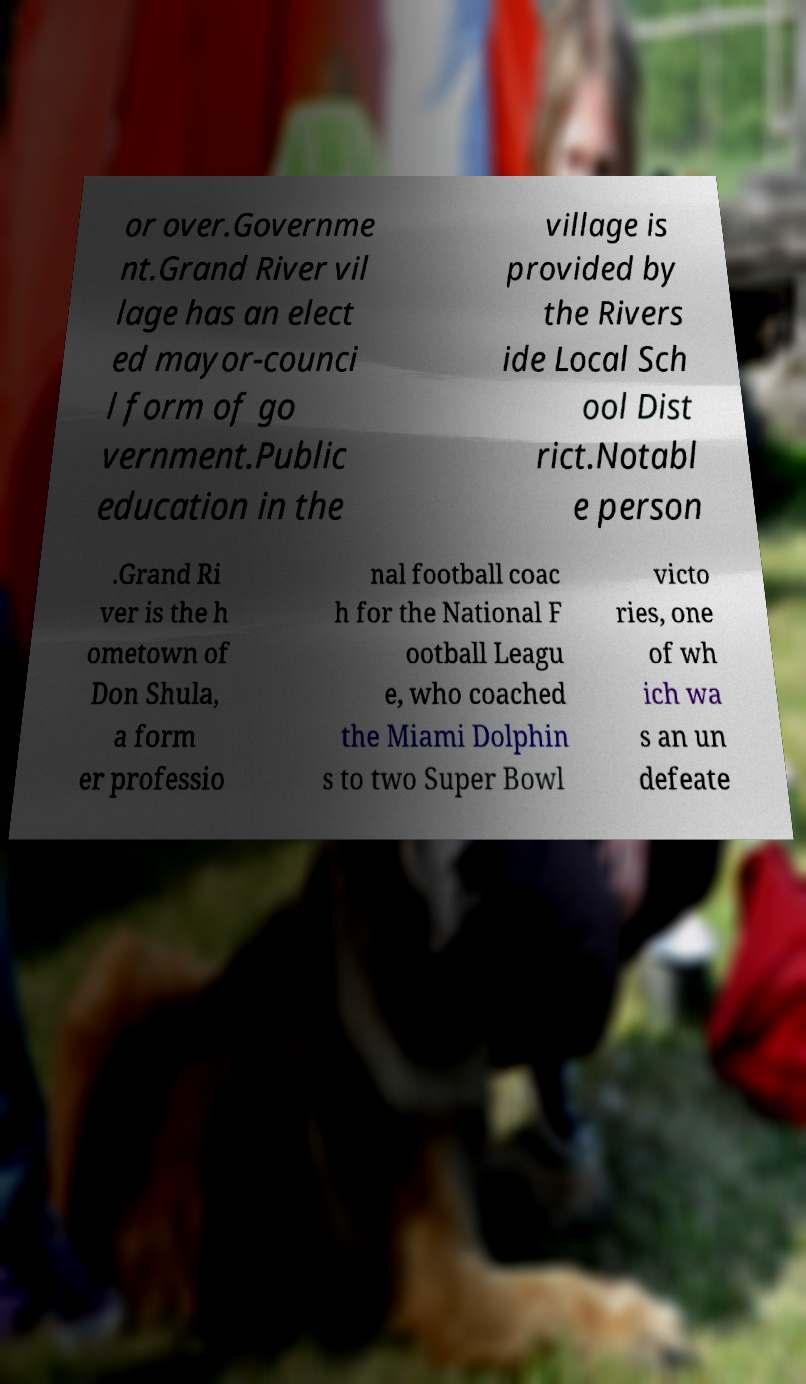For documentation purposes, I need the text within this image transcribed. Could you provide that? or over.Governme nt.Grand River vil lage has an elect ed mayor-counci l form of go vernment.Public education in the village is provided by the Rivers ide Local Sch ool Dist rict.Notabl e person .Grand Ri ver is the h ometown of Don Shula, a form er professio nal football coac h for the National F ootball Leagu e, who coached the Miami Dolphin s to two Super Bowl victo ries, one of wh ich wa s an un defeate 